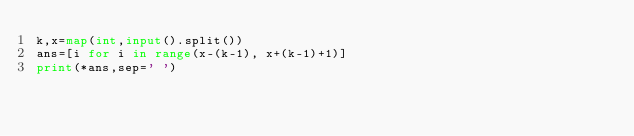Convert code to text. <code><loc_0><loc_0><loc_500><loc_500><_Python_>k,x=map(int,input().split())
ans=[i for i in range(x-(k-1), x+(k-1)+1)]
print(*ans,sep=' ')</code> 